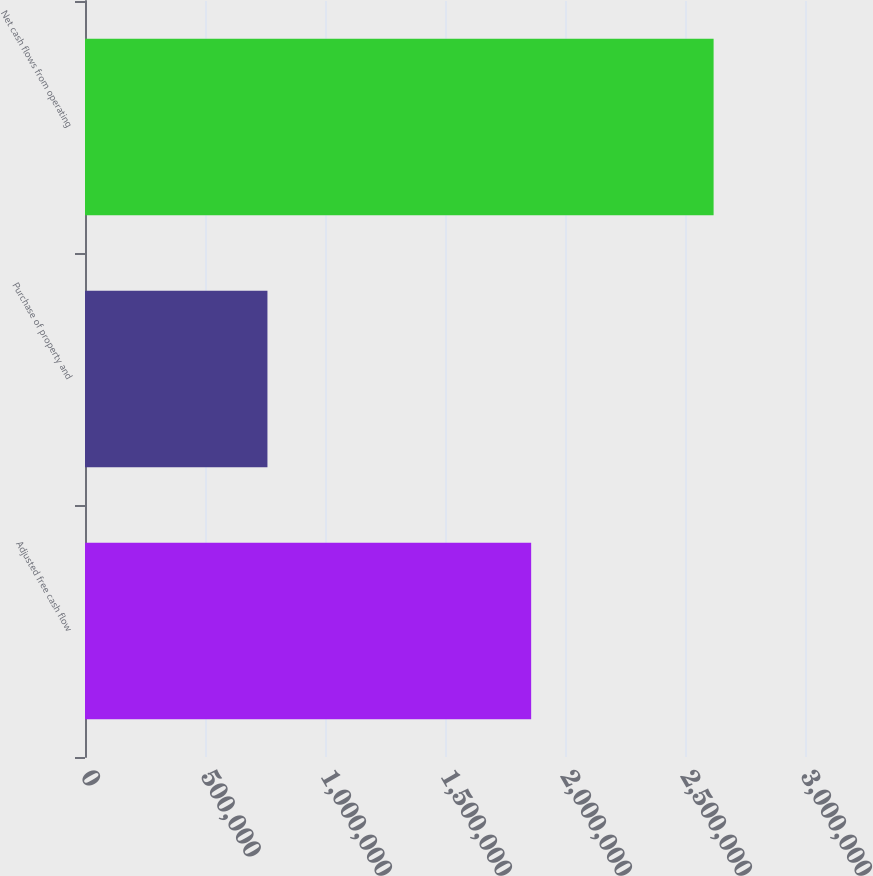Convert chart to OTSL. <chart><loc_0><loc_0><loc_500><loc_500><bar_chart><fcel>Adjusted free cash flow<fcel>Purchase of property and<fcel>Net cash flows from operating<nl><fcel>1.859e+06<fcel>760158<fcel>2.61916e+06<nl></chart> 